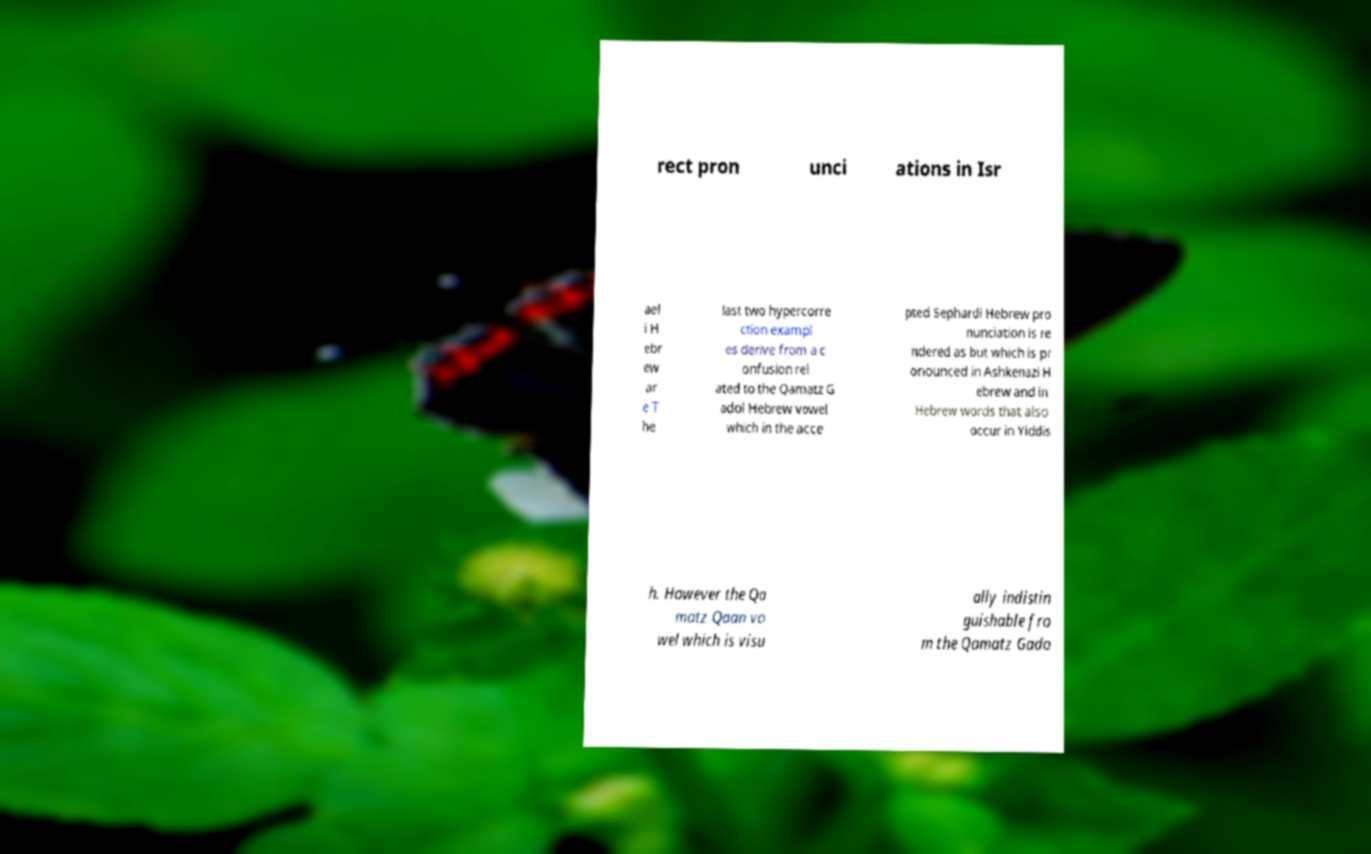Please read and relay the text visible in this image. What does it say? rect pron unci ations in Isr ael i H ebr ew ar e T he last two hypercorre ction exampl es derive from a c onfusion rel ated to the Qamatz G adol Hebrew vowel which in the acce pted Sephardi Hebrew pro nunciation is re ndered as but which is pr onounced in Ashkenazi H ebrew and in Hebrew words that also occur in Yiddis h. However the Qa matz Qaan vo wel which is visu ally indistin guishable fro m the Qamatz Gado 